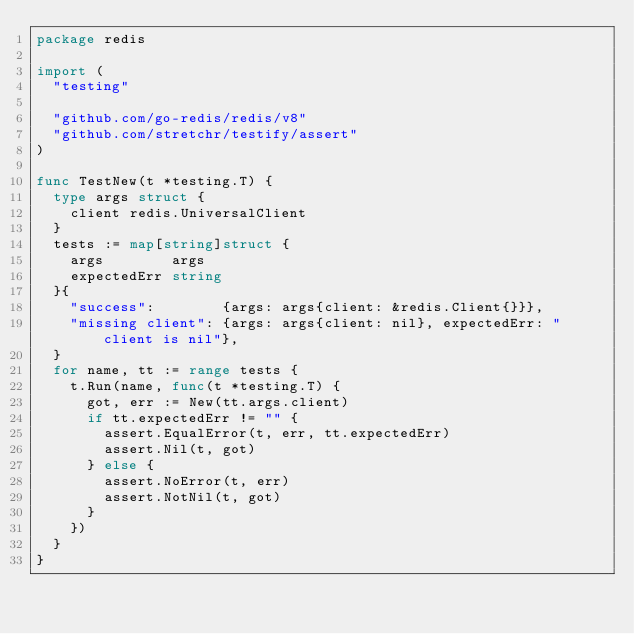Convert code to text. <code><loc_0><loc_0><loc_500><loc_500><_Go_>package redis

import (
	"testing"

	"github.com/go-redis/redis/v8"
	"github.com/stretchr/testify/assert"
)

func TestNew(t *testing.T) {
	type args struct {
		client redis.UniversalClient
	}
	tests := map[string]struct {
		args        args
		expectedErr string
	}{
		"success":        {args: args{client: &redis.Client{}}},
		"missing client": {args: args{client: nil}, expectedErr: "client is nil"},
	}
	for name, tt := range tests {
		t.Run(name, func(t *testing.T) {
			got, err := New(tt.args.client)
			if tt.expectedErr != "" {
				assert.EqualError(t, err, tt.expectedErr)
				assert.Nil(t, got)
			} else {
				assert.NoError(t, err)
				assert.NotNil(t, got)
			}
		})
	}
}
</code> 